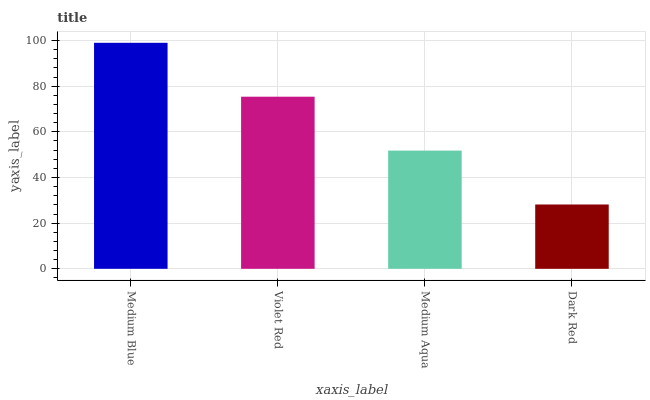Is Dark Red the minimum?
Answer yes or no. Yes. Is Medium Blue the maximum?
Answer yes or no. Yes. Is Violet Red the minimum?
Answer yes or no. No. Is Violet Red the maximum?
Answer yes or no. No. Is Medium Blue greater than Violet Red?
Answer yes or no. Yes. Is Violet Red less than Medium Blue?
Answer yes or no. Yes. Is Violet Red greater than Medium Blue?
Answer yes or no. No. Is Medium Blue less than Violet Red?
Answer yes or no. No. Is Violet Red the high median?
Answer yes or no. Yes. Is Medium Aqua the low median?
Answer yes or no. Yes. Is Medium Aqua the high median?
Answer yes or no. No. Is Medium Blue the low median?
Answer yes or no. No. 